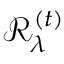<formula> <loc_0><loc_0><loc_500><loc_500>\mathcal { R } _ { \lambda } ^ { ( t ) }</formula> 